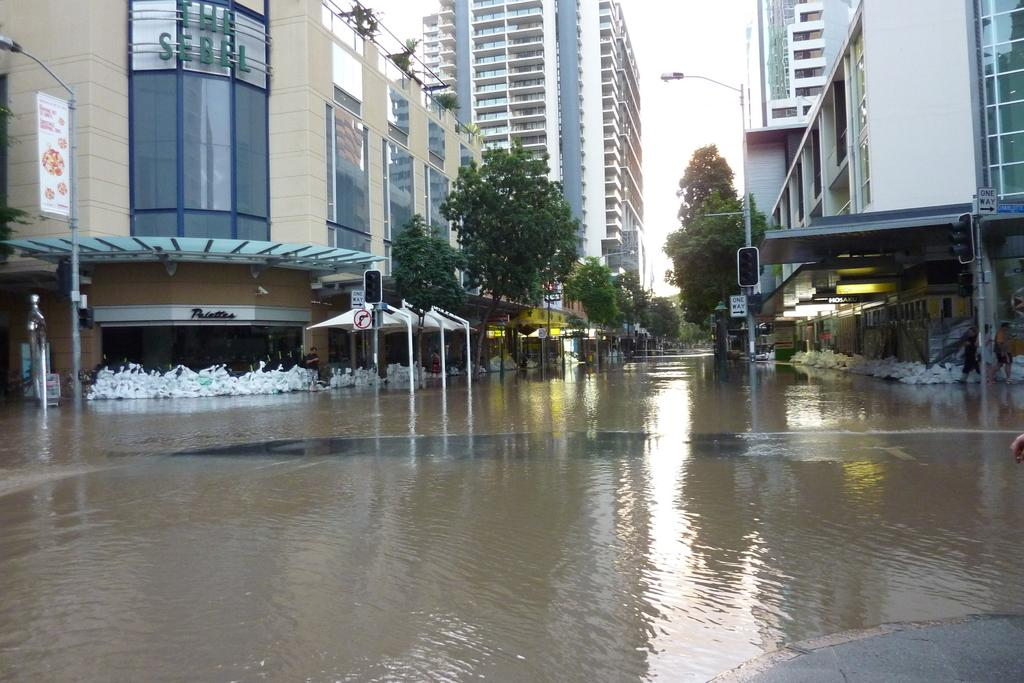What is on the road in the image? There is water on the road in the image. What can be seen in the distance in the image? There are buildings, trees, and poles in the background of the image. What is the purpose of the brick in the image? There is no brick present in the image. 